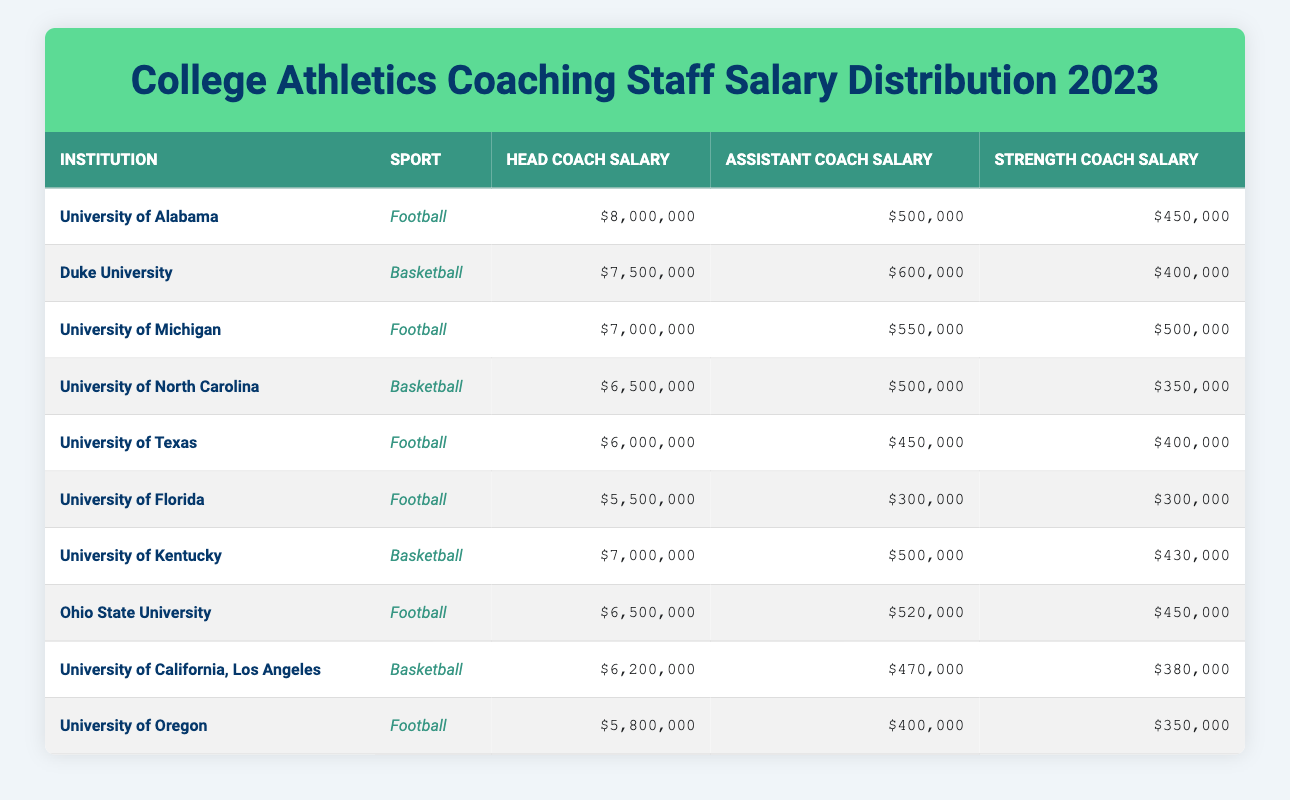What is the head coach salary for the University of Alabama? The table lists the University of Alabama under the institution column with its respective head coach salary. According to the data, the head coach salary for the University of Alabama is $8,000,000.
Answer: $8,000,000 Which institution has the highest head coach salary? By examining the head coach salaries across all institutions, the highest value is found in the row for the University of Alabama, which has a salary of $8,000,000, while all others are lower than this amount.
Answer: University of Alabama What is the average assistant coach salary for all football programs? The football programs listed are: University of Alabama ($500,000), University of Michigan ($550,000), University of Texas ($450,000), University of Florida ($300,000), Ohio State University ($520,000), and University of Oregon ($400,000). The average assistant coach salary is calculated by adding these amounts (500,000 + 550,000 + 450,000 + 300,000 + 520,000 + 400,000 = 2,720,000) and dividing by 6, giving 2,720,000 / 6 = 453,333.33.
Answer: $453,333.33 Is there any institution with an assistant coach salary above $600,000? Scanning through the assistant coach salaries, we see the highest value is $600,000 from Duke University. However, no other institution listed has an assistant coach salary that equals or exceeds this figure, confirming that the statement is true for only Duke University.
Answer: Yes Which sport has a lower average strength coach salary: football or basketball? The strength coach salaries for football are: $450,000 (Alabama), $500,000 (Michigan), $400,000 (Texas), $300,000 (Florida), $450,000 (Ohio State), and $350,000 (Oregon) totaling $2,300,000 and averaging to $383,333.33. The basketball strength coach salaries are: $400,000 (Duke), $350,000 (North Carolina), $430,000 (Kentucky), $380,000 (UCLA), giving a total of $1,560,000 and an average of $390,000. Comparing both averages shows that the football average ($383,333.33) is lower than that for basketball ($390,000).
Answer: Football What is the total head coach salary for all institutions listed? To find the total head coach salary, we add the salaries from all given institutions: $8,000,000 (Alabama) + $7,500,000 (Duke) + $7,000,000 (Michigan) + $6,500,000 (North Carolina) + $6,000,000 (Texas) + $5,500,000 (Florida) + $7,000,000 (Kentucky) + $6,500,000 (Ohio State) + $6,200,000 (UCLA) + $5,800,000 (Oregon) = $60,100,000.
Answer: $60,100,000 Does the University of Florida have the lowest assistant coach salary among football programs? Checking assistant coach salaries for football, we find that University of Florida has $300,000, which is less than the amounts listed for the other institutions (University of Alabama: $500,000, Michigan: $550,000, Texas: $450,000, Ohio State: $520,000, or Oregon: $400,000). This confirms that the University of Florida indeed has the lowest assistant coach salary among football programs.
Answer: Yes How does the strength coach salary of the University of Kentucky compare to that of Ohio State University? The strength coach salary for the University of Kentucky is $430,000, while for Ohio State University, it is $450,000. Thus, comparing the two shows that Ohio State University's strength coach salary ($450,000) is higher than Kentucky's ($430,000) by $20,000.
Answer: Ohio State University has a higher salary 